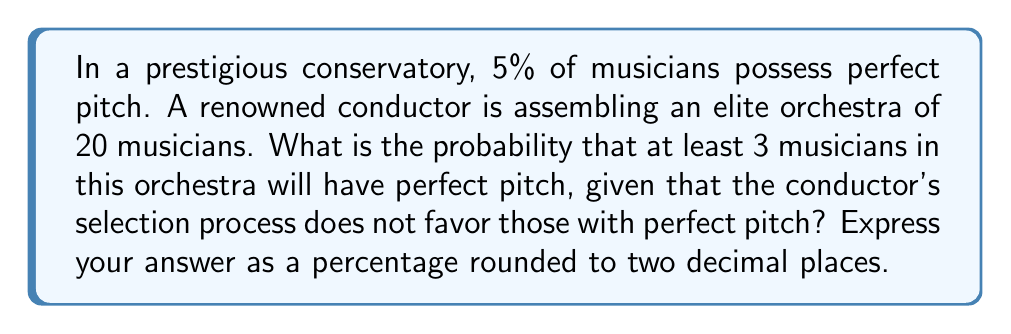Give your solution to this math problem. Let's approach this step-by-step using the binomial probability distribution:

1) Let X be the number of musicians with perfect pitch in the orchestra.
   X follows a binomial distribution with n = 20 and p = 0.05

2) We need to find P(X ≥ 3)

3) This is equivalent to 1 - P(X < 3) = 1 - [P(X = 0) + P(X = 1) + P(X = 2)]

4) The probability mass function for a binomial distribution is:

   $$P(X = k) = \binom{n}{k} p^k (1-p)^{n-k}$$

5) Let's calculate each probability:

   P(X = 0) = $\binom{20}{0} (0.05)^0 (0.95)^{20}$ = 0.3585

   P(X = 1) = $\binom{20}{1} (0.05)^1 (0.95)^{19}$ = 0.3774

   P(X = 2) = $\binom{20}{2} (0.05)^2 (0.95)^{18}$ = 0.1887

6) Now, we can calculate P(X ≥ 3):

   P(X ≥ 3) = 1 - [P(X = 0) + P(X = 1) + P(X = 2)]
             = 1 - (0.3585 + 0.3774 + 0.1887)
             = 1 - 0.9246
             = 0.0754

7) Converting to a percentage and rounding to two decimal places:

   0.0754 * 100 ≈ 7.54%
Answer: 7.54% 